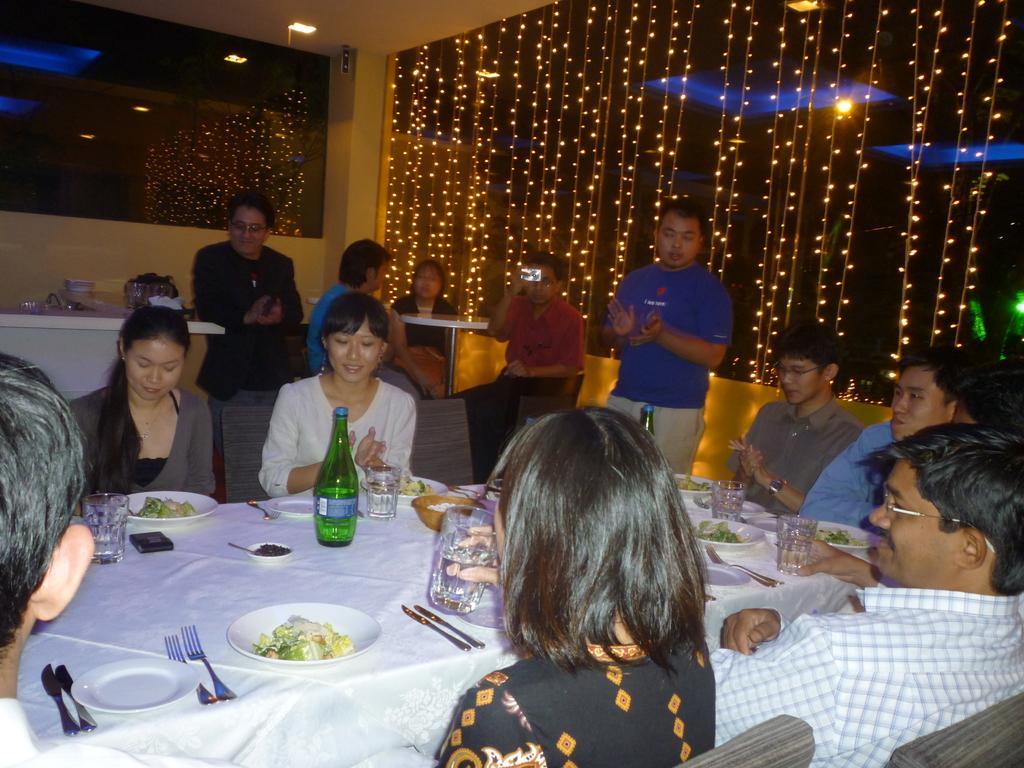Could you give a brief overview of what you see in this image? There are group of people sitting in chairs and there is a table in front of them which has some eatables and drinks on it and there are few people in the background. 